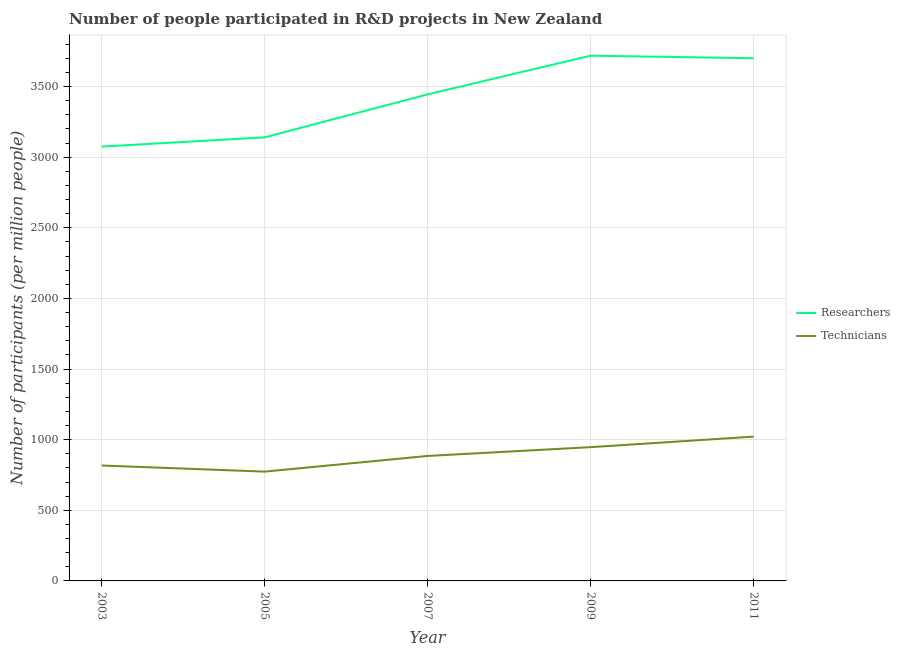How many different coloured lines are there?
Your response must be concise. 2. Does the line corresponding to number of researchers intersect with the line corresponding to number of technicians?
Offer a terse response. No. Is the number of lines equal to the number of legend labels?
Offer a very short reply. Yes. What is the number of researchers in 2011?
Give a very brief answer. 3700.77. Across all years, what is the maximum number of researchers?
Ensure brevity in your answer.  3719. Across all years, what is the minimum number of researchers?
Make the answer very short. 3075.22. In which year was the number of technicians minimum?
Your answer should be very brief. 2005. What is the total number of technicians in the graph?
Ensure brevity in your answer.  4444.67. What is the difference between the number of technicians in 2005 and that in 2007?
Ensure brevity in your answer.  -110.91. What is the difference between the number of researchers in 2011 and the number of technicians in 2009?
Keep it short and to the point. 2753.7. What is the average number of researchers per year?
Offer a very short reply. 3416.15. In the year 2005, what is the difference between the number of researchers and number of technicians?
Your answer should be very brief. 2366.8. What is the ratio of the number of researchers in 2005 to that in 2009?
Provide a succinct answer. 0.84. Is the number of technicians in 2009 less than that in 2011?
Make the answer very short. Yes. What is the difference between the highest and the second highest number of researchers?
Your response must be concise. 18.22. What is the difference between the highest and the lowest number of technicians?
Offer a very short reply. 247.75. Does the number of researchers monotonically increase over the years?
Give a very brief answer. No. Is the number of technicians strictly greater than the number of researchers over the years?
Offer a very short reply. No. Is the number of researchers strictly less than the number of technicians over the years?
Ensure brevity in your answer.  No. How many lines are there?
Offer a very short reply. 2. Does the graph contain any zero values?
Provide a short and direct response. No. Where does the legend appear in the graph?
Give a very brief answer. Center right. What is the title of the graph?
Ensure brevity in your answer.  Number of people participated in R&D projects in New Zealand. Does "Secondary Education" appear as one of the legend labels in the graph?
Give a very brief answer. No. What is the label or title of the Y-axis?
Give a very brief answer. Number of participants (per million people). What is the Number of participants (per million people) in Researchers in 2003?
Offer a very short reply. 3075.22. What is the Number of participants (per million people) of Technicians in 2003?
Your answer should be very brief. 817.12. What is the Number of participants (per million people) of Researchers in 2005?
Provide a succinct answer. 3140.74. What is the Number of participants (per million people) of Technicians in 2005?
Provide a short and direct response. 773.94. What is the Number of participants (per million people) of Researchers in 2007?
Your answer should be compact. 3445. What is the Number of participants (per million people) in Technicians in 2007?
Offer a very short reply. 884.85. What is the Number of participants (per million people) of Researchers in 2009?
Your answer should be compact. 3719. What is the Number of participants (per million people) of Technicians in 2009?
Offer a very short reply. 947.07. What is the Number of participants (per million people) of Researchers in 2011?
Make the answer very short. 3700.77. What is the Number of participants (per million people) in Technicians in 2011?
Your answer should be very brief. 1021.69. Across all years, what is the maximum Number of participants (per million people) in Researchers?
Offer a terse response. 3719. Across all years, what is the maximum Number of participants (per million people) of Technicians?
Make the answer very short. 1021.69. Across all years, what is the minimum Number of participants (per million people) in Researchers?
Give a very brief answer. 3075.22. Across all years, what is the minimum Number of participants (per million people) of Technicians?
Your response must be concise. 773.94. What is the total Number of participants (per million people) in Researchers in the graph?
Your answer should be compact. 1.71e+04. What is the total Number of participants (per million people) of Technicians in the graph?
Give a very brief answer. 4444.67. What is the difference between the Number of participants (per million people) in Researchers in 2003 and that in 2005?
Your answer should be compact. -65.51. What is the difference between the Number of participants (per million people) of Technicians in 2003 and that in 2005?
Make the answer very short. 43.19. What is the difference between the Number of participants (per million people) of Researchers in 2003 and that in 2007?
Give a very brief answer. -369.78. What is the difference between the Number of participants (per million people) in Technicians in 2003 and that in 2007?
Your response must be concise. -67.72. What is the difference between the Number of participants (per million people) of Researchers in 2003 and that in 2009?
Offer a very short reply. -643.77. What is the difference between the Number of participants (per million people) in Technicians in 2003 and that in 2009?
Your answer should be very brief. -129.95. What is the difference between the Number of participants (per million people) of Researchers in 2003 and that in 2011?
Provide a succinct answer. -625.55. What is the difference between the Number of participants (per million people) of Technicians in 2003 and that in 2011?
Provide a short and direct response. -204.56. What is the difference between the Number of participants (per million people) in Researchers in 2005 and that in 2007?
Offer a very short reply. -304.27. What is the difference between the Number of participants (per million people) in Technicians in 2005 and that in 2007?
Your response must be concise. -110.91. What is the difference between the Number of participants (per million people) in Researchers in 2005 and that in 2009?
Provide a succinct answer. -578.26. What is the difference between the Number of participants (per million people) in Technicians in 2005 and that in 2009?
Offer a very short reply. -173.14. What is the difference between the Number of participants (per million people) in Researchers in 2005 and that in 2011?
Your answer should be compact. -560.04. What is the difference between the Number of participants (per million people) in Technicians in 2005 and that in 2011?
Give a very brief answer. -247.75. What is the difference between the Number of participants (per million people) of Researchers in 2007 and that in 2009?
Provide a succinct answer. -273.99. What is the difference between the Number of participants (per million people) of Technicians in 2007 and that in 2009?
Keep it short and to the point. -62.23. What is the difference between the Number of participants (per million people) in Researchers in 2007 and that in 2011?
Offer a terse response. -255.77. What is the difference between the Number of participants (per million people) in Technicians in 2007 and that in 2011?
Your response must be concise. -136.84. What is the difference between the Number of participants (per million people) in Researchers in 2009 and that in 2011?
Ensure brevity in your answer.  18.22. What is the difference between the Number of participants (per million people) in Technicians in 2009 and that in 2011?
Provide a short and direct response. -74.61. What is the difference between the Number of participants (per million people) of Researchers in 2003 and the Number of participants (per million people) of Technicians in 2005?
Give a very brief answer. 2301.29. What is the difference between the Number of participants (per million people) of Researchers in 2003 and the Number of participants (per million people) of Technicians in 2007?
Provide a short and direct response. 2190.38. What is the difference between the Number of participants (per million people) in Researchers in 2003 and the Number of participants (per million people) in Technicians in 2009?
Make the answer very short. 2128.15. What is the difference between the Number of participants (per million people) in Researchers in 2003 and the Number of participants (per million people) in Technicians in 2011?
Ensure brevity in your answer.  2053.54. What is the difference between the Number of participants (per million people) of Researchers in 2005 and the Number of participants (per million people) of Technicians in 2007?
Your answer should be very brief. 2255.89. What is the difference between the Number of participants (per million people) of Researchers in 2005 and the Number of participants (per million people) of Technicians in 2009?
Your answer should be very brief. 2193.66. What is the difference between the Number of participants (per million people) of Researchers in 2005 and the Number of participants (per million people) of Technicians in 2011?
Provide a short and direct response. 2119.05. What is the difference between the Number of participants (per million people) in Researchers in 2007 and the Number of participants (per million people) in Technicians in 2009?
Give a very brief answer. 2497.93. What is the difference between the Number of participants (per million people) of Researchers in 2007 and the Number of participants (per million people) of Technicians in 2011?
Your response must be concise. 2423.32. What is the difference between the Number of participants (per million people) of Researchers in 2009 and the Number of participants (per million people) of Technicians in 2011?
Provide a short and direct response. 2697.31. What is the average Number of participants (per million people) of Researchers per year?
Ensure brevity in your answer.  3416.15. What is the average Number of participants (per million people) in Technicians per year?
Keep it short and to the point. 888.93. In the year 2003, what is the difference between the Number of participants (per million people) of Researchers and Number of participants (per million people) of Technicians?
Offer a very short reply. 2258.1. In the year 2005, what is the difference between the Number of participants (per million people) of Researchers and Number of participants (per million people) of Technicians?
Provide a succinct answer. 2366.8. In the year 2007, what is the difference between the Number of participants (per million people) of Researchers and Number of participants (per million people) of Technicians?
Keep it short and to the point. 2560.16. In the year 2009, what is the difference between the Number of participants (per million people) of Researchers and Number of participants (per million people) of Technicians?
Offer a terse response. 2771.92. In the year 2011, what is the difference between the Number of participants (per million people) in Researchers and Number of participants (per million people) in Technicians?
Ensure brevity in your answer.  2679.09. What is the ratio of the Number of participants (per million people) of Researchers in 2003 to that in 2005?
Provide a succinct answer. 0.98. What is the ratio of the Number of participants (per million people) of Technicians in 2003 to that in 2005?
Provide a short and direct response. 1.06. What is the ratio of the Number of participants (per million people) in Researchers in 2003 to that in 2007?
Your answer should be compact. 0.89. What is the ratio of the Number of participants (per million people) of Technicians in 2003 to that in 2007?
Ensure brevity in your answer.  0.92. What is the ratio of the Number of participants (per million people) of Researchers in 2003 to that in 2009?
Ensure brevity in your answer.  0.83. What is the ratio of the Number of participants (per million people) of Technicians in 2003 to that in 2009?
Ensure brevity in your answer.  0.86. What is the ratio of the Number of participants (per million people) in Researchers in 2003 to that in 2011?
Your answer should be very brief. 0.83. What is the ratio of the Number of participants (per million people) of Technicians in 2003 to that in 2011?
Offer a terse response. 0.8. What is the ratio of the Number of participants (per million people) of Researchers in 2005 to that in 2007?
Offer a very short reply. 0.91. What is the ratio of the Number of participants (per million people) in Technicians in 2005 to that in 2007?
Provide a short and direct response. 0.87. What is the ratio of the Number of participants (per million people) in Researchers in 2005 to that in 2009?
Make the answer very short. 0.84. What is the ratio of the Number of participants (per million people) of Technicians in 2005 to that in 2009?
Your response must be concise. 0.82. What is the ratio of the Number of participants (per million people) in Researchers in 2005 to that in 2011?
Give a very brief answer. 0.85. What is the ratio of the Number of participants (per million people) of Technicians in 2005 to that in 2011?
Ensure brevity in your answer.  0.76. What is the ratio of the Number of participants (per million people) in Researchers in 2007 to that in 2009?
Offer a terse response. 0.93. What is the ratio of the Number of participants (per million people) of Technicians in 2007 to that in 2009?
Provide a short and direct response. 0.93. What is the ratio of the Number of participants (per million people) of Researchers in 2007 to that in 2011?
Offer a very short reply. 0.93. What is the ratio of the Number of participants (per million people) of Technicians in 2007 to that in 2011?
Make the answer very short. 0.87. What is the ratio of the Number of participants (per million people) in Researchers in 2009 to that in 2011?
Provide a succinct answer. 1. What is the ratio of the Number of participants (per million people) of Technicians in 2009 to that in 2011?
Offer a very short reply. 0.93. What is the difference between the highest and the second highest Number of participants (per million people) of Researchers?
Give a very brief answer. 18.22. What is the difference between the highest and the second highest Number of participants (per million people) of Technicians?
Your response must be concise. 74.61. What is the difference between the highest and the lowest Number of participants (per million people) in Researchers?
Your answer should be compact. 643.77. What is the difference between the highest and the lowest Number of participants (per million people) in Technicians?
Offer a terse response. 247.75. 